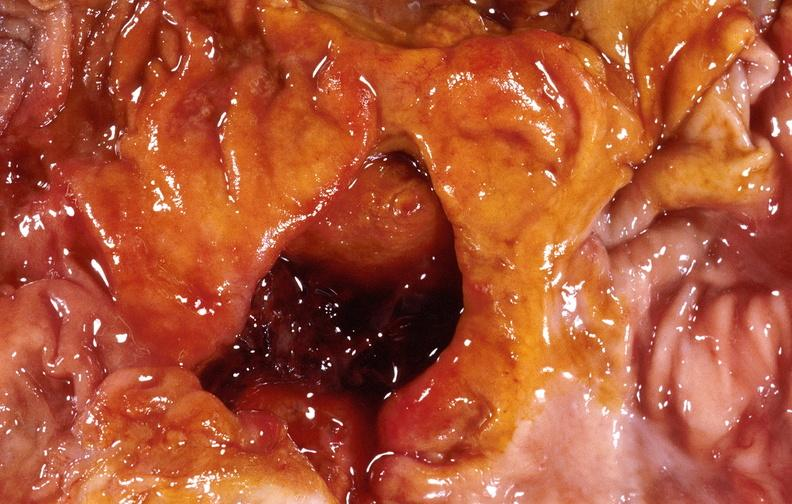does this image show duodenal ulcer?
Answer the question using a single word or phrase. Yes 